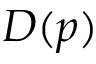<formula> <loc_0><loc_0><loc_500><loc_500>D ( p )</formula> 